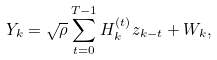<formula> <loc_0><loc_0><loc_500><loc_500>Y _ { k } = \sqrt { \rho } \sum _ { t = 0 } ^ { T - 1 } H _ { k } ^ { ( t ) } z _ { k - t } + W _ { k } ,</formula> 